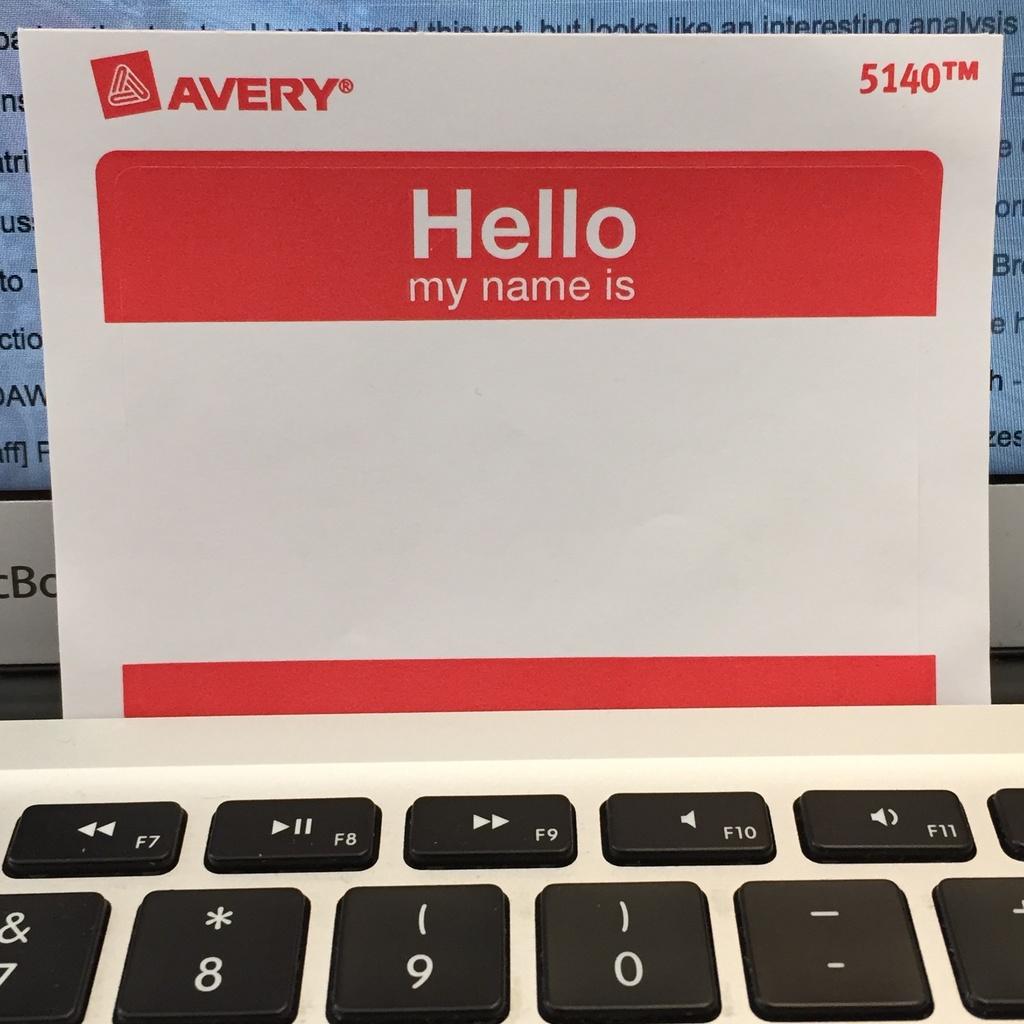What brand is this name tag sticker?
Provide a short and direct response. Avery. What is the model number of this name tag?
Offer a terse response. 5140. 